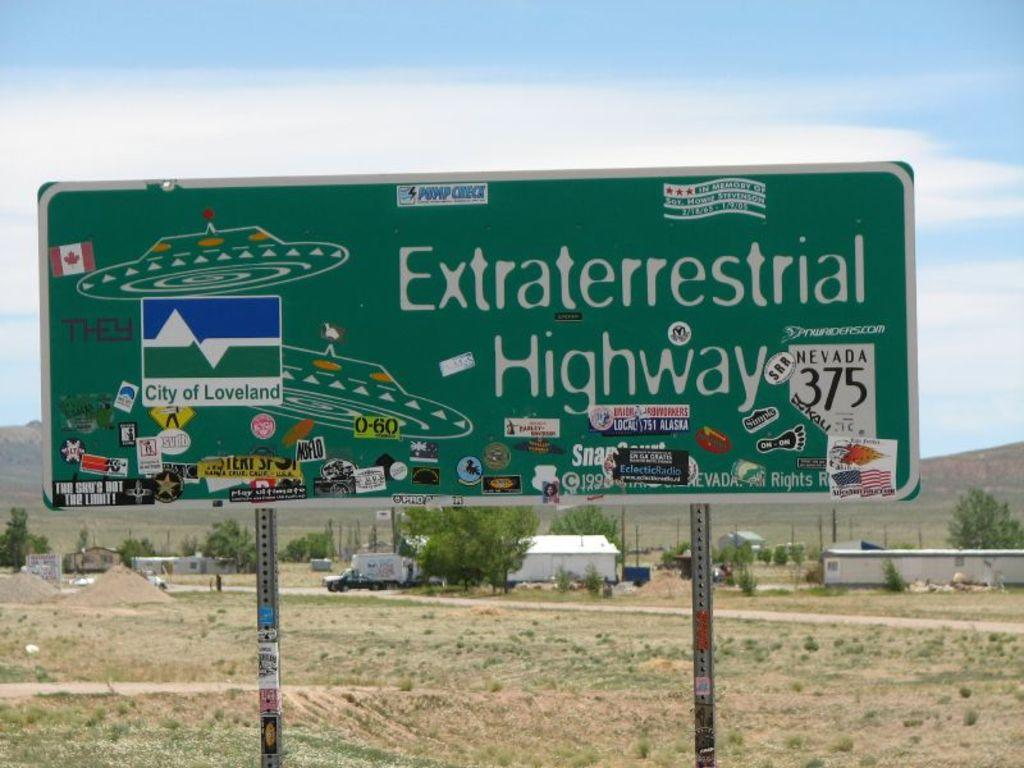<image>
Offer a succinct explanation of the picture presented. a sign for Extraterrestrial Highway has lots of stickers on it 